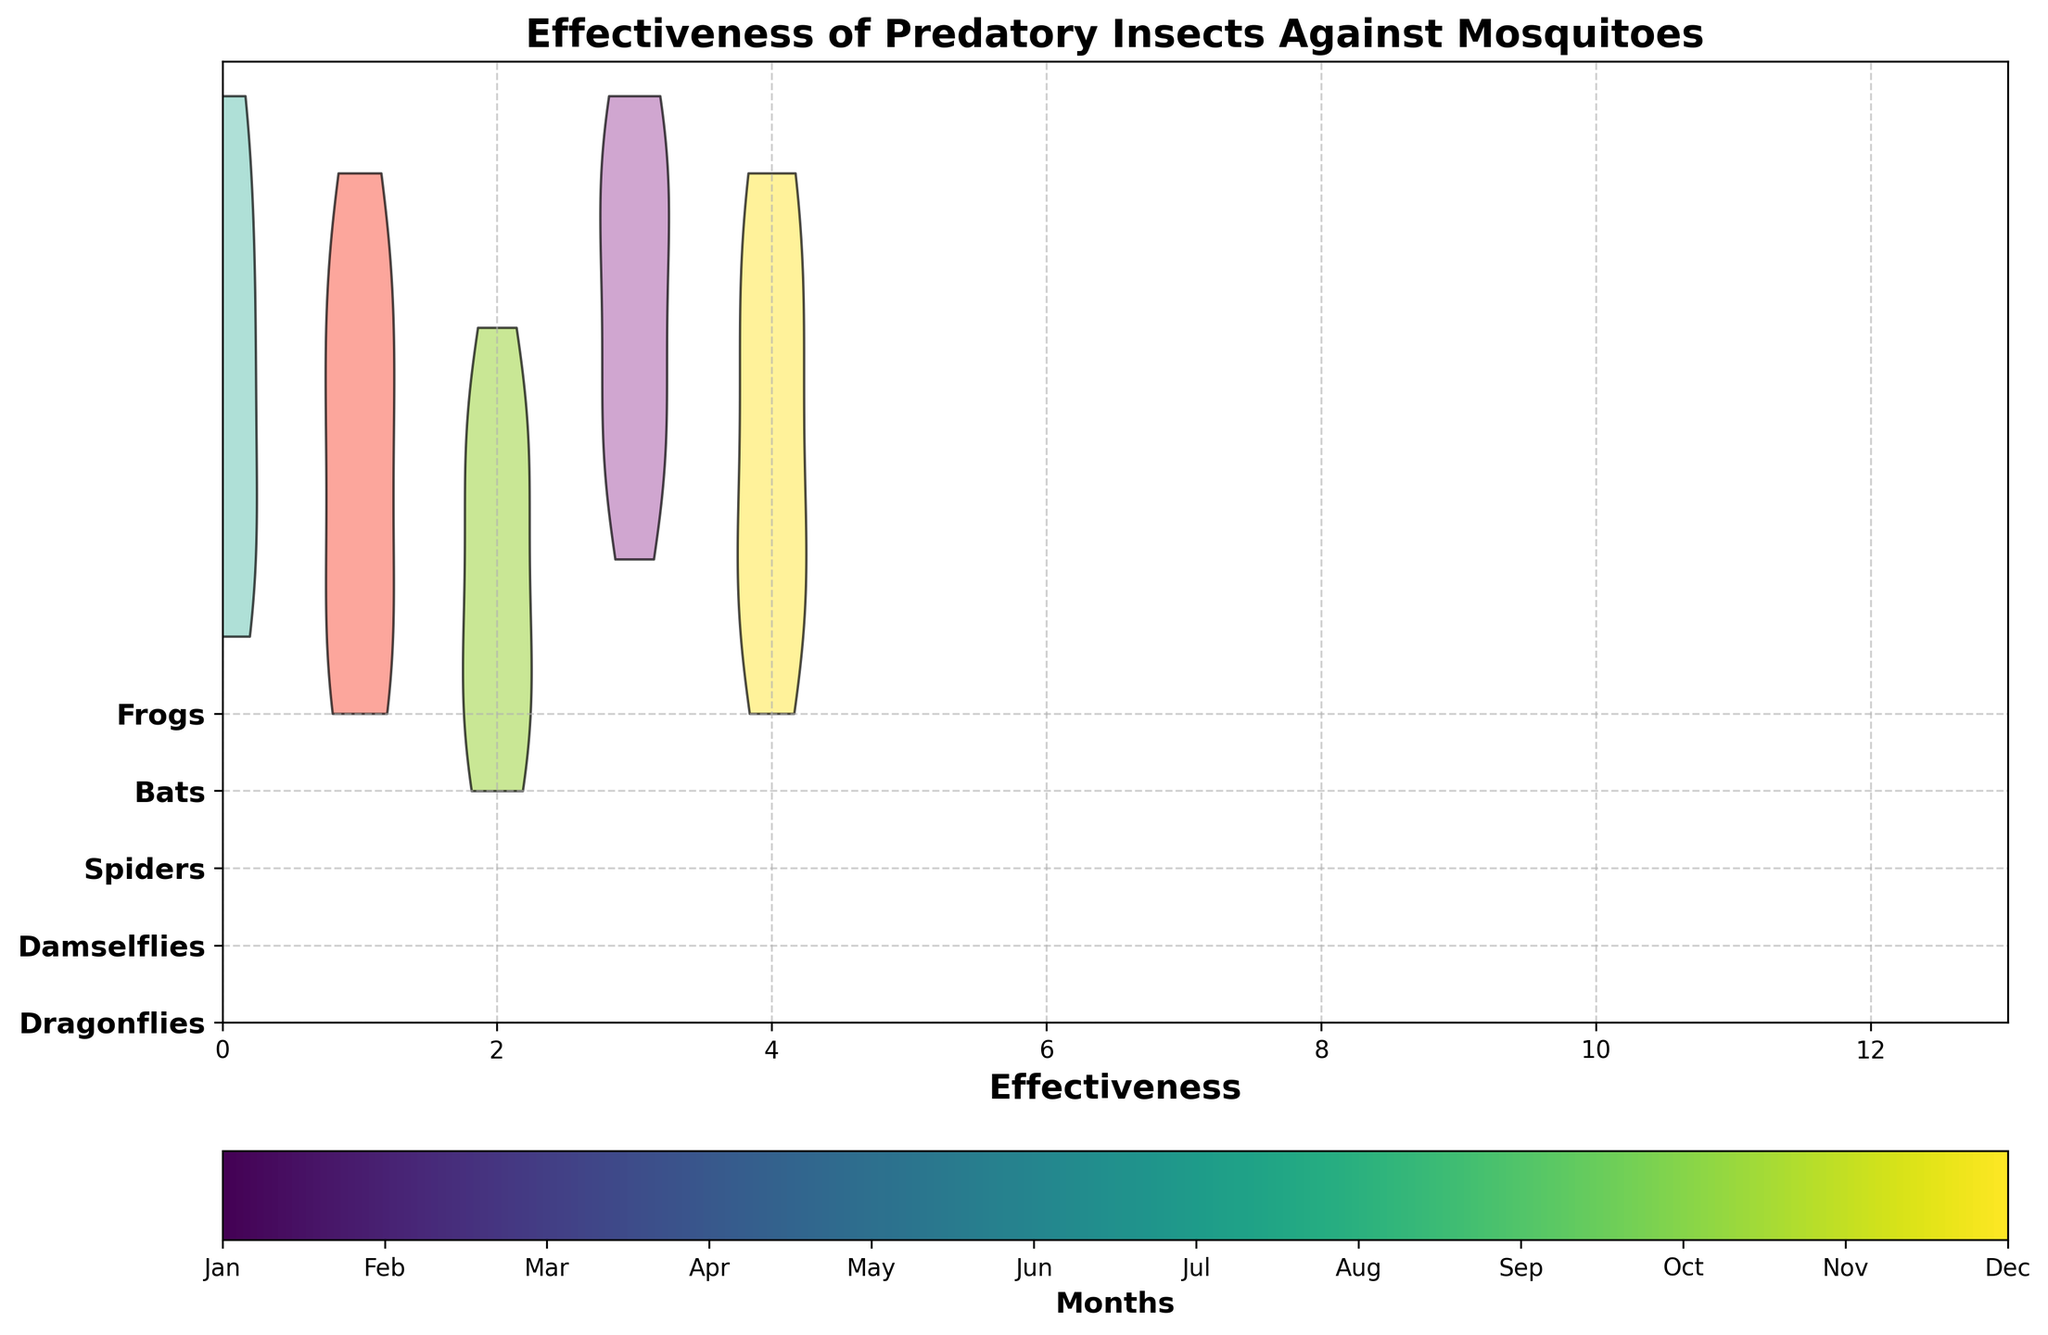What's the title of the plot? The title is at the top of the chart, centered and usually in a larger font size.
Answer: Effectiveness of Predatory Insects Against Mosquitoes Which insect type shows the highest effectiveness in July? To determine this, observe the violin charts corresponding to July. The violin chart showing the broadest distribution peak at the highest value represents the insect with the highest effectiveness in July.
Answer: Dragonflies and Bats How does the effectiveness of spiders compare in March and September? Look at the position and spread of the violin plots for spiders in March and September. The broader or higher the violin plot, the higher the effectiveness.
Answer: Effectiveness is higher in September Which month is illustrated by the color bar at the far left? The color bar ranges horizontal at the bottom of the chart and maps to months. The value on the far left corresponds to the first label on the color bar.
Answer: January What is the average effectiveness of Bats throughout the year? To find the average, sum the effectiveness values for Bats across all months and divide by 12 (the number of months). (7+8+9+10+11+12+12+11+10+8+7+6)/12 = 9.25.
Answer: 9.25 In which month do Dragonflies and Frogs both have their lowest effectiveness? Identify the months where both Dragonflies and Frogs have the narrowest and shortest violin plots indicating lowest effectiveness.
Answer: January How does the effectiveness of Damselflies in June compare to that in December? Compare the positions and shapes of the violin plots for Damselflies in June and December. Higher positions and broader plots indicate higher effectiveness.
Answer: Higher in June Which insect shows the highest variation in effectiveness throughout the year? Shifts in the width of the violin plots across months indicate variation. The insect with the most varied violin shapes and widths shows the highest variation.
Answer: Dragonflies or Bats 